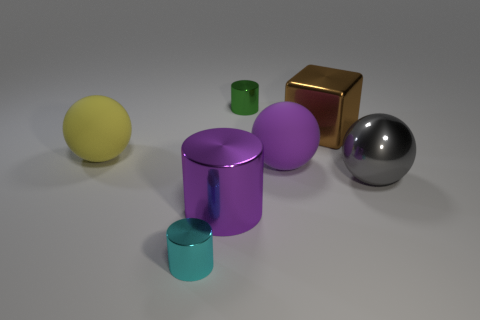Does the big cylinder have the same color as the big metal block?
Provide a short and direct response. No. The purple shiny object that is the same shape as the green shiny object is what size?
Offer a terse response. Large. How many large blue cylinders are made of the same material as the purple cylinder?
Give a very brief answer. 0. Is the purple thing that is behind the gray metallic object made of the same material as the large gray thing?
Your answer should be very brief. No. Are there the same number of purple cylinders in front of the large shiny cylinder and green metallic cylinders?
Provide a succinct answer. No. What size is the gray sphere?
Ensure brevity in your answer.  Large. There is a thing that is the same color as the big shiny cylinder; what is it made of?
Your response must be concise. Rubber. What number of big metallic spheres have the same color as the shiny block?
Make the answer very short. 0. Do the purple ball and the brown object have the same size?
Provide a succinct answer. Yes. How big is the shiny object that is in front of the large metallic object that is left of the metal cube?
Keep it short and to the point. Small. 